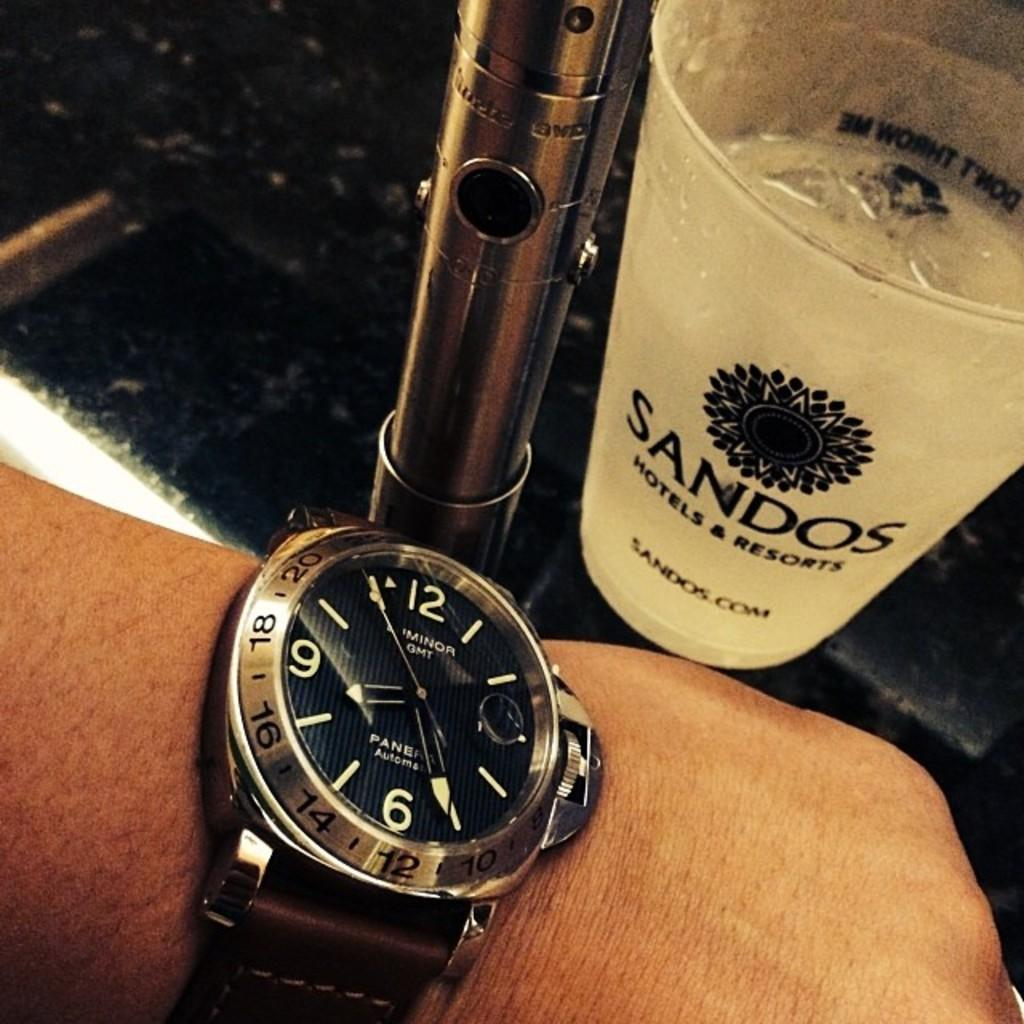Provide a one-sentence caption for the provided image. A wrist watch and a cup with the Sandos name on it. 